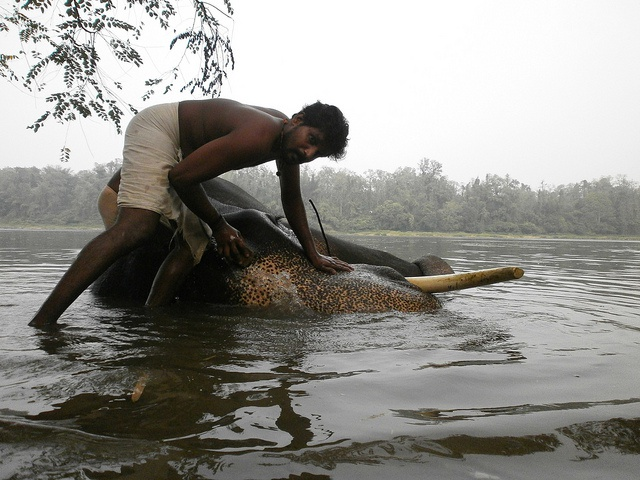Describe the objects in this image and their specific colors. I can see people in white, black, maroon, and gray tones, elephant in white, black, and gray tones, and people in white, maroon, gray, and black tones in this image. 